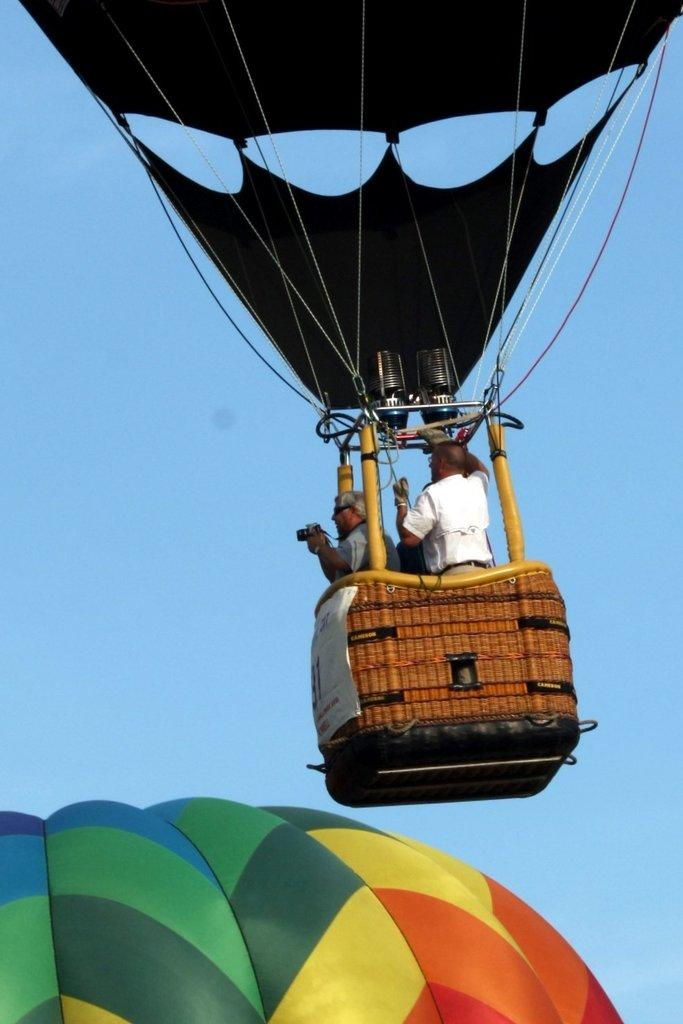What are the people in the image doing? The persons in the image are standing in a hot air balloon. What can be seen in the background of the image? The sky is visible in the background of the image. What type of jam is being spread on the patch in the image? There is no jam or patch present in the image; it features a hot air balloon with people inside and a sky background. 